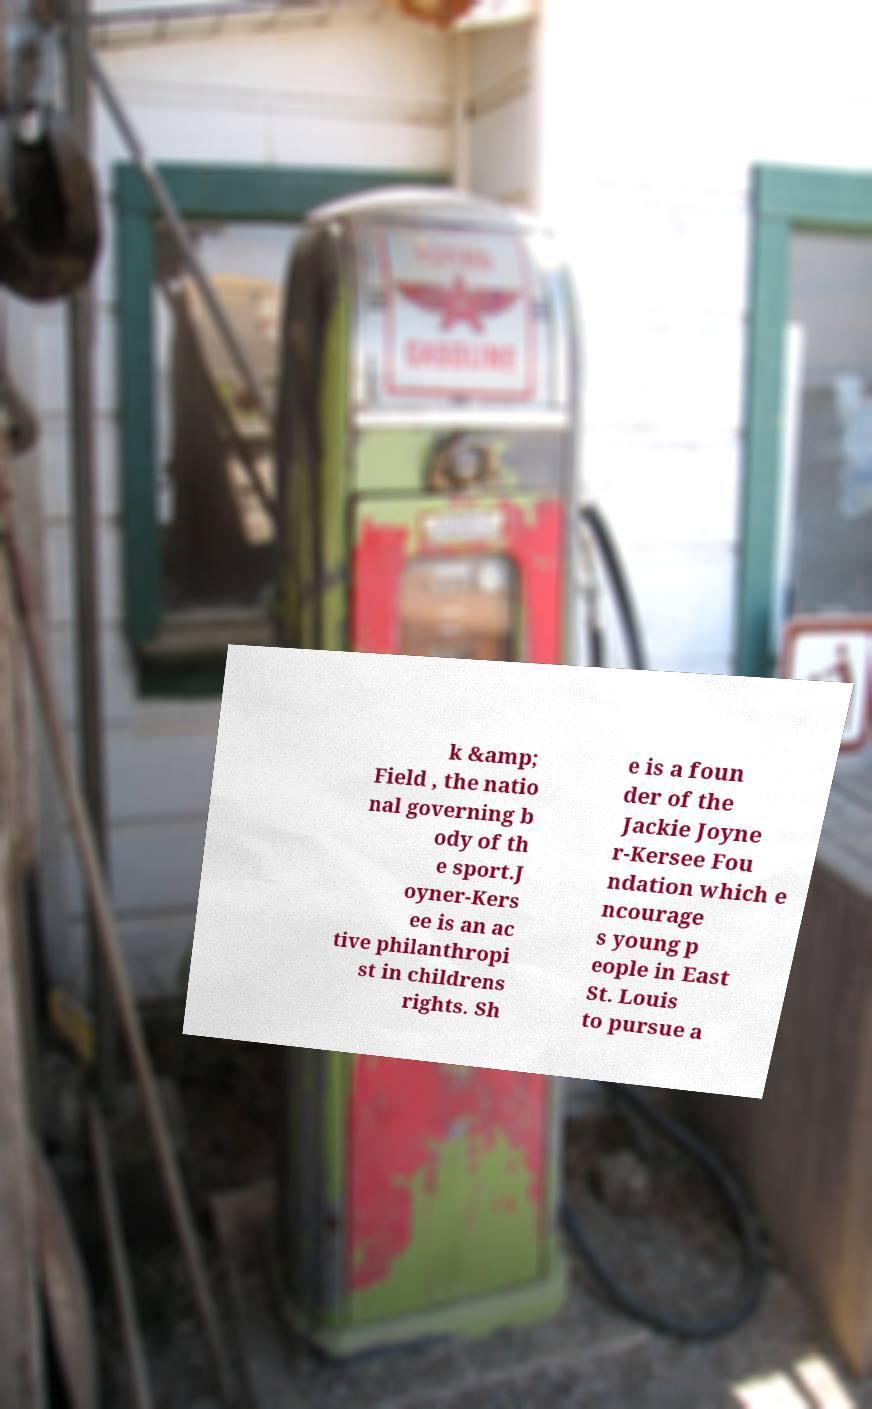What messages or text are displayed in this image? I need them in a readable, typed format. k &amp; Field , the natio nal governing b ody of th e sport.J oyner-Kers ee is an ac tive philanthropi st in childrens rights. Sh e is a foun der of the Jackie Joyne r-Kersee Fou ndation which e ncourage s young p eople in East St. Louis to pursue a 